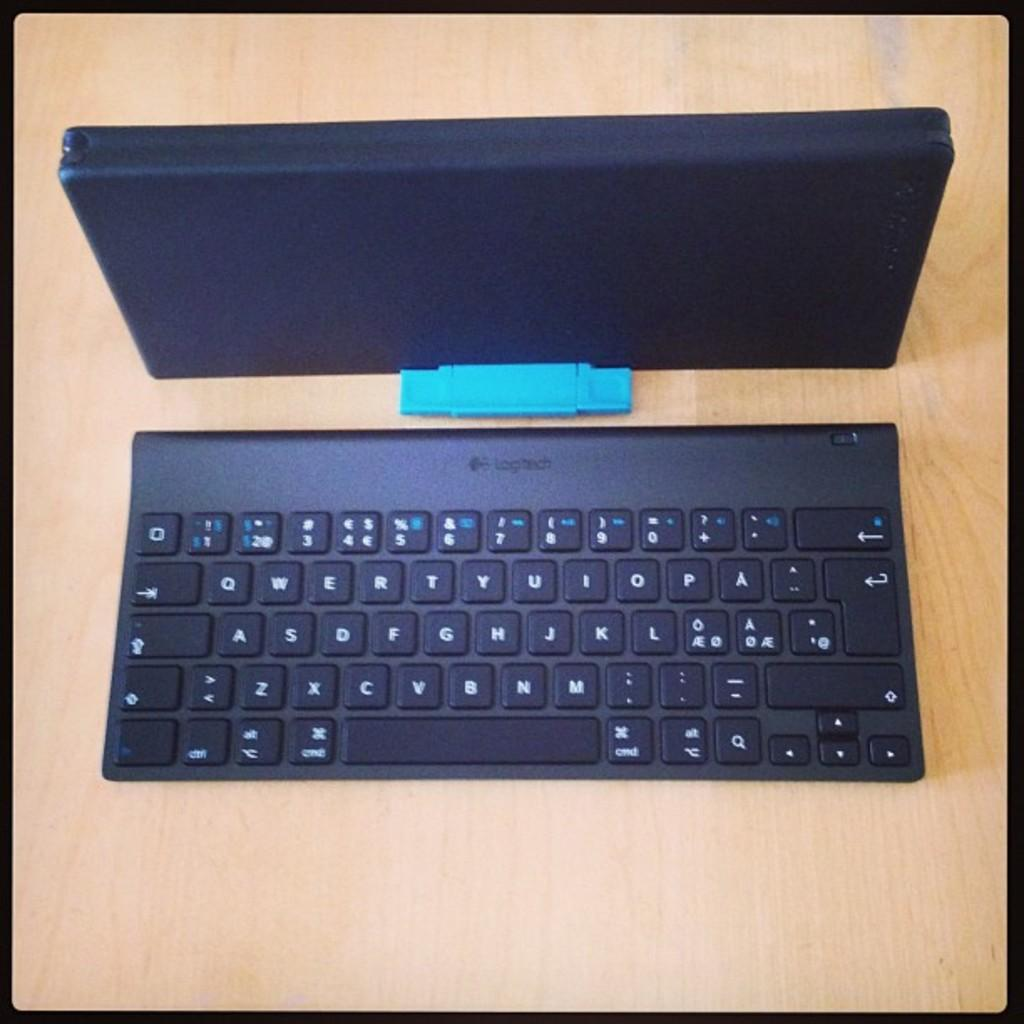<image>
Provide a brief description of the given image. A black Logitech keyboard sitting on a wooden table. 